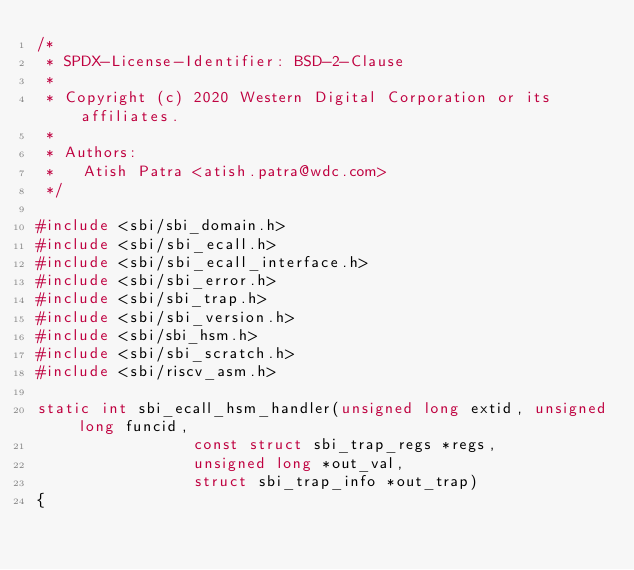Convert code to text. <code><loc_0><loc_0><loc_500><loc_500><_C_>/*
 * SPDX-License-Identifier: BSD-2-Clause
 *
 * Copyright (c) 2020 Western Digital Corporation or its affiliates.
 *
 * Authors:
 *   Atish Patra <atish.patra@wdc.com>
 */

#include <sbi/sbi_domain.h>
#include <sbi/sbi_ecall.h>
#include <sbi/sbi_ecall_interface.h>
#include <sbi/sbi_error.h>
#include <sbi/sbi_trap.h>
#include <sbi/sbi_version.h>
#include <sbi/sbi_hsm.h>
#include <sbi/sbi_scratch.h>
#include <sbi/riscv_asm.h>

static int sbi_ecall_hsm_handler(unsigned long extid, unsigned long funcid,
				 const struct sbi_trap_regs *regs,
				 unsigned long *out_val,
				 struct sbi_trap_info *out_trap)
{</code> 